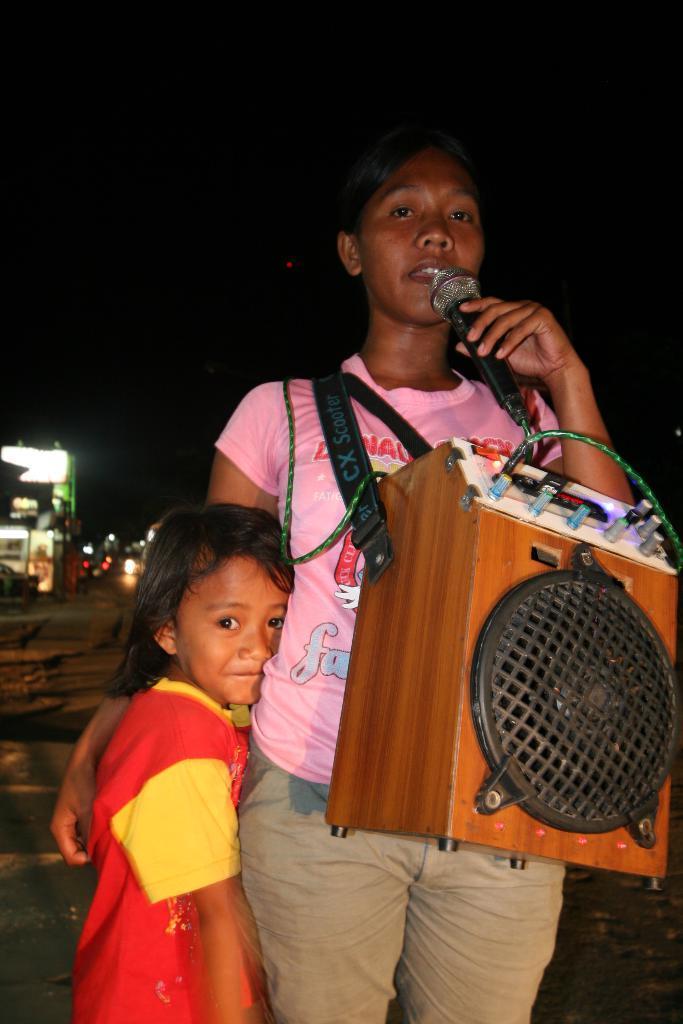In one or two sentences, can you explain what this image depicts? In this picture we can see woman and girl standing and here woman holding mic in her hand and carrying speakers and this girl is laughing and in the background we can see building, lights and it is dark. 